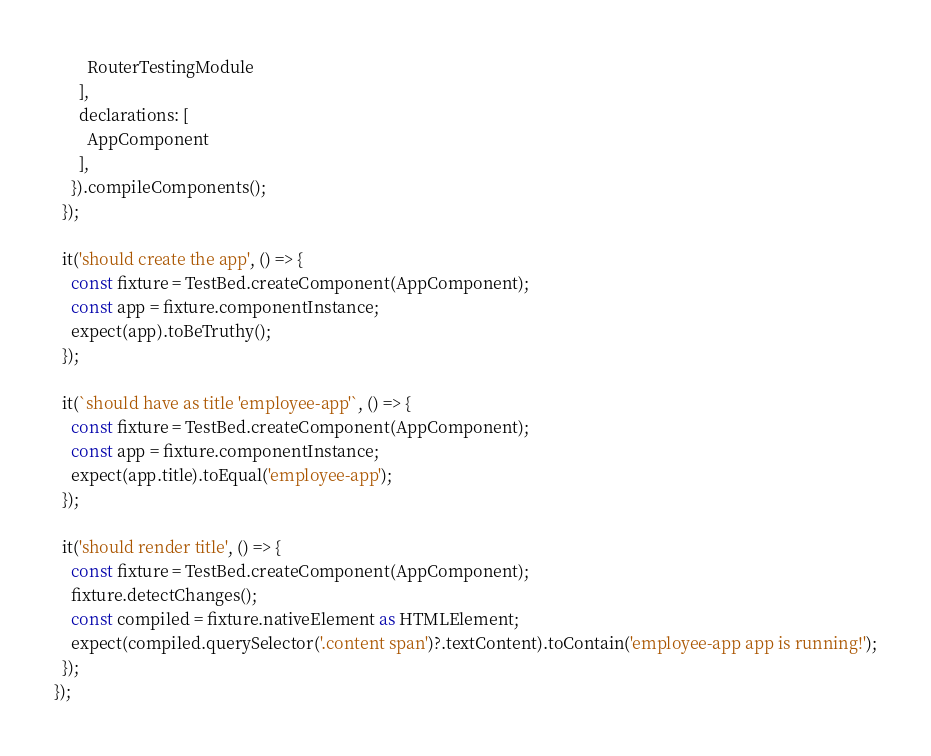<code> <loc_0><loc_0><loc_500><loc_500><_TypeScript_>        RouterTestingModule
      ],
      declarations: [
        AppComponent
      ],
    }).compileComponents();
  });

  it('should create the app', () => {
    const fixture = TestBed.createComponent(AppComponent);
    const app = fixture.componentInstance;
    expect(app).toBeTruthy();
  });

  it(`should have as title 'employee-app'`, () => {
    const fixture = TestBed.createComponent(AppComponent);
    const app = fixture.componentInstance;
    expect(app.title).toEqual('employee-app');
  });

  it('should render title', () => {
    const fixture = TestBed.createComponent(AppComponent);
    fixture.detectChanges();
    const compiled = fixture.nativeElement as HTMLElement;
    expect(compiled.querySelector('.content span')?.textContent).toContain('employee-app app is running!');
  });
});
</code> 